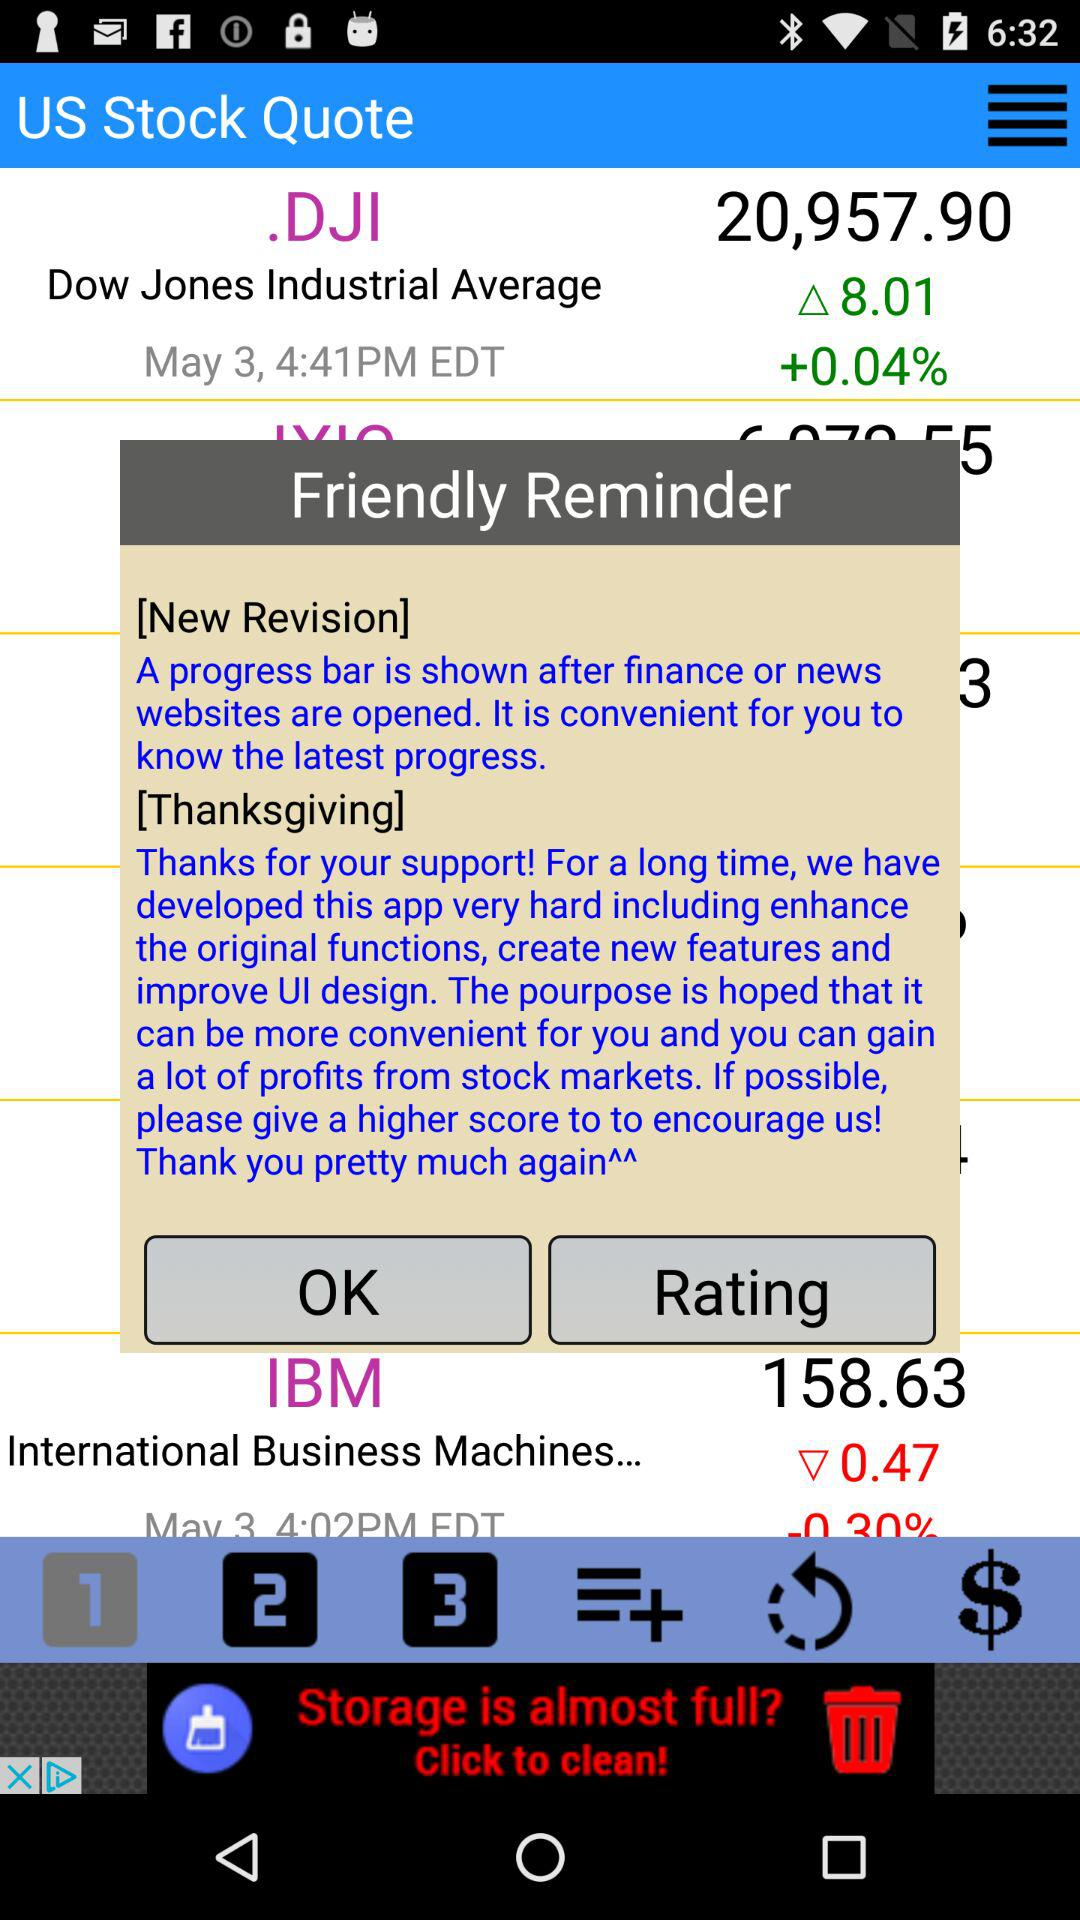At what time was the stock price of.DJI updated? It was updated at 4:41 PM. 